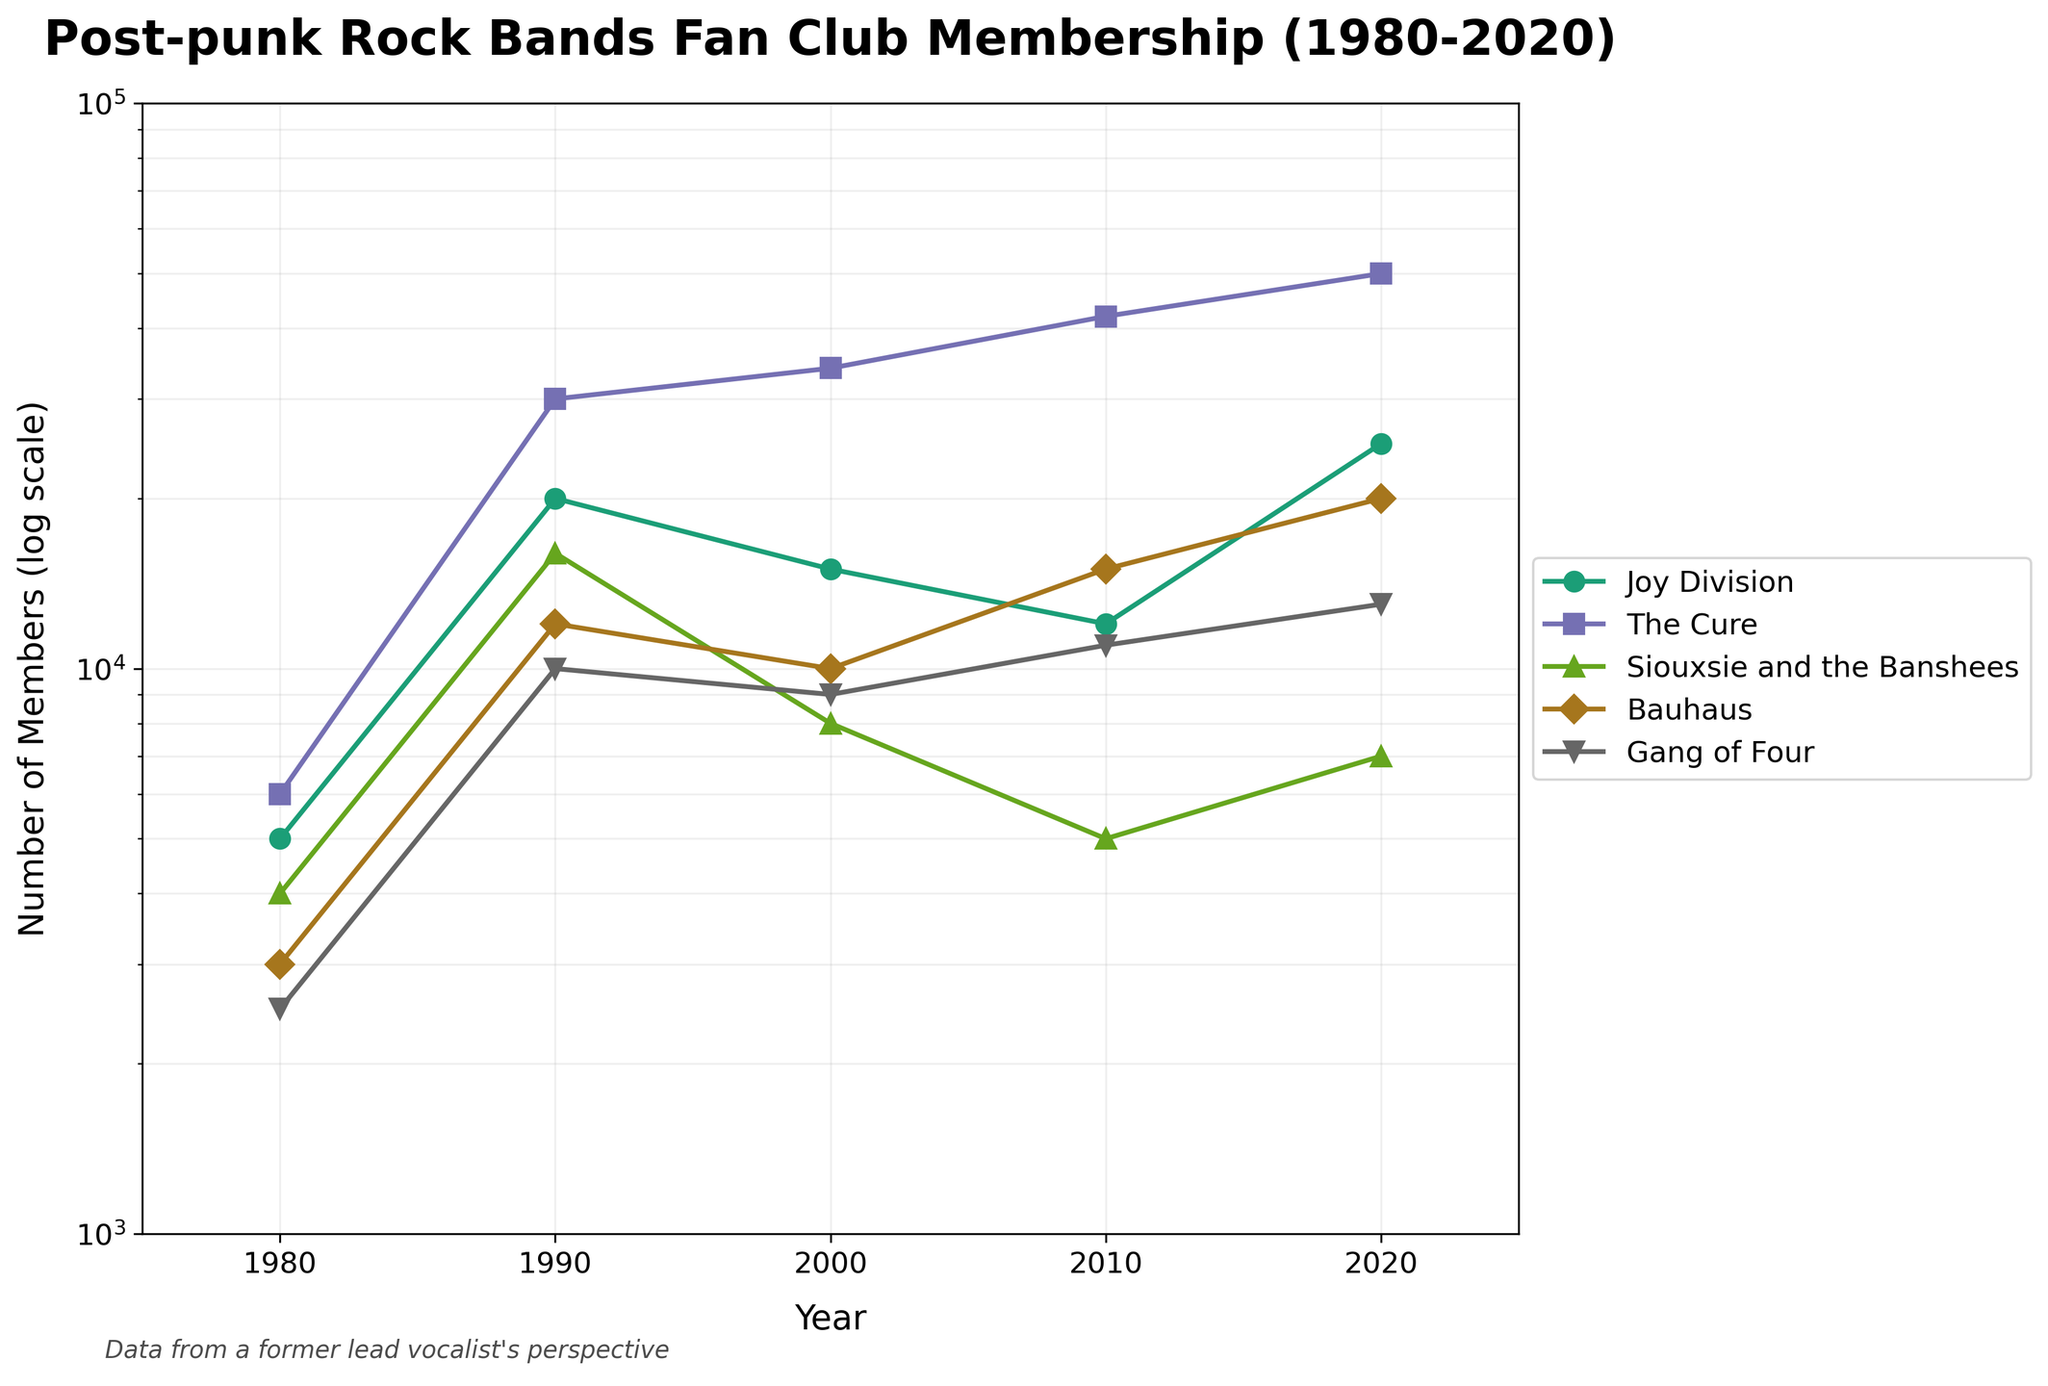What is the title of the plot? The title of the plot is written in bold at the top of the figure and reads "Post-punk Rock Bands Fan Club Membership (1980-2020)".
Answer: Post-punk Rock Bands Fan Club Membership (1980-2020) Which band had the highest membership in 2020? By looking at the log scale and following the data points for each band to the year 2020, it's clear that "The Cure" had the highest membership.
Answer: The Cure How did Joy Division's membership numbers change from 1980 to 2020? Joy Division's membership numbers in 1980 were 5,000 and increased to 25,000 by 2020. The overall trend is an increase.
Answer: Increased Between 2000 to 2010, which band saw a decrease in membership numbers? Siouxsie and the Banshees saw a decrease in membership numbers from 8,000 in 2000 to 5,000 in 2010.
Answer: Siouxsie and the Banshees Which two bands had equal membership numbers in 2000? According to the plot, both Joy Division and Bauhaus had membership numbers that appeared to be around 15,000 members in 2000.
Answer: Joy Division and Bauhaus Calculate the average membership number for The Cure from 1980 to 2020. The membership numbers for The Cure are [6000, 30000, 34000, 42000, 50000]. The average is (6000 + 30000 + 34000 + 42000 + 50000) / 5 = 32400.
Answer: 32400 Which band experienced the most significant decline in membership numbers between any two consecutive decades? To find this, we compare the differences for each band between each pair of consecutive decades. Siouxsie and the Banshees had the most significant decline, from 16,000 in 1990 to 8,000 in 2000, a decrease of 8,000 members.
Answer: Siouxsie and the Banshees How many bands are represented in the plot? By looking at the legend and the distinctly colored lines, we can see there are five bands represented.
Answer: Five Which period saw the highest increase in membership numbers for Bauhaus? The highest increase for Bauhaus occurred between 2010 and 2020, where the membership grew from 15,000 to 20,000, an increase of 5,000 members.
Answer: Between 2010 and 2020 Compare the trends of Joy Division and The Cure from 2010 to 2020. Joy Division's membership increased from 12,000 to 25,000, showing a significant upward trend. The Cure's membership increased from 42,000 to 50,000, indicating a smaller but still upward trend. Both bands show increasing trends, but Joy Division's is more pronounced.
Answer: Both increased; Joy Division increased more 